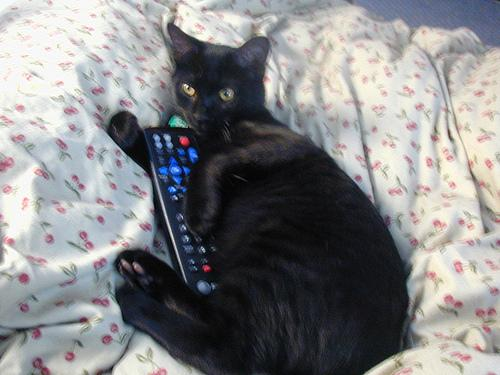What is the cat in control of? remote 